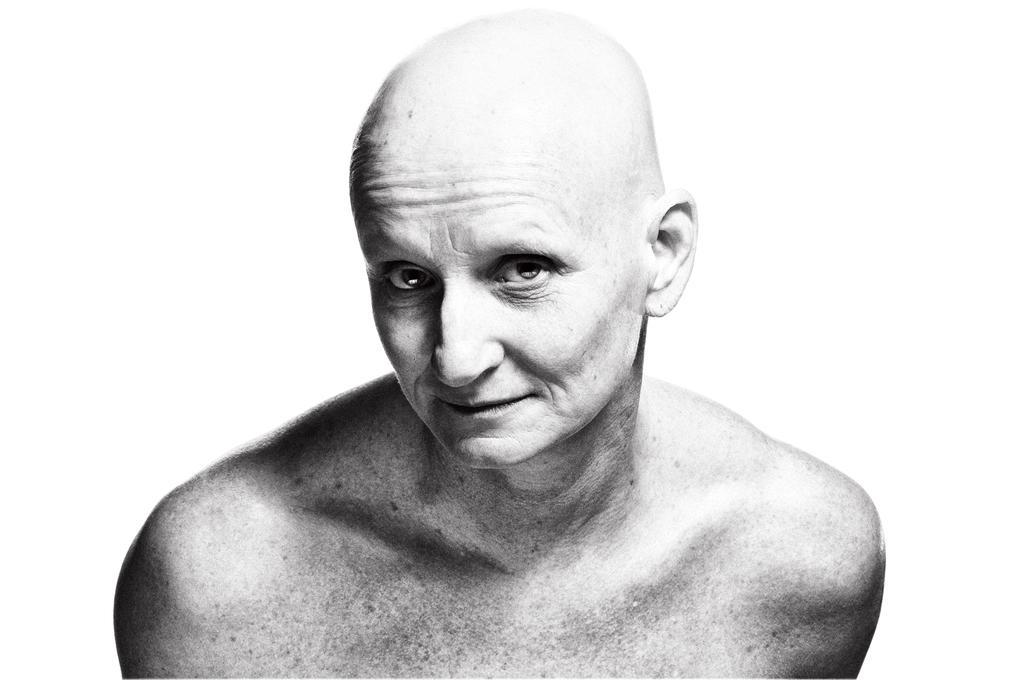How would you summarize this image in a sentence or two? In this picture there is an old man with bald hair smiling in giving a pose into the camera. Behind there is a white background. 